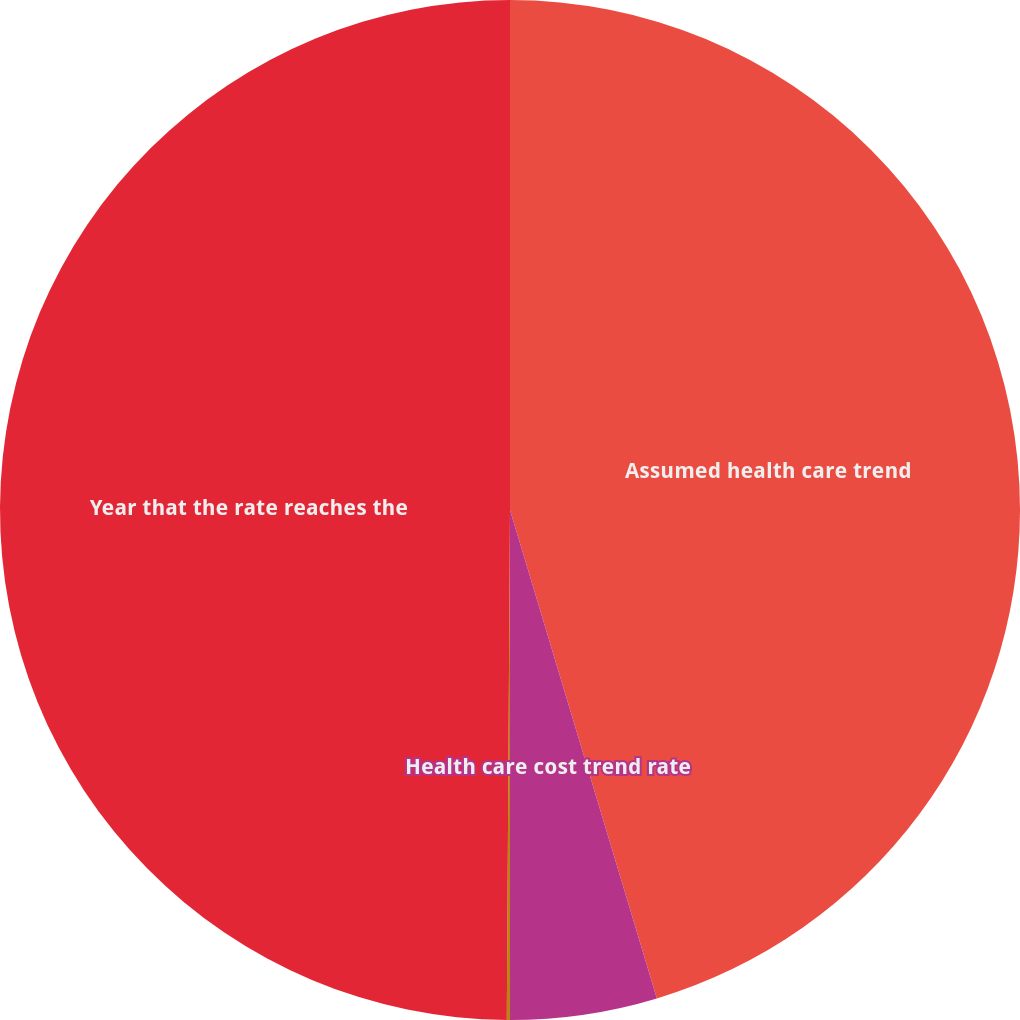<chart> <loc_0><loc_0><loc_500><loc_500><pie_chart><fcel>Assumed health care trend<fcel>Health care cost trend rate<fcel>Rate to which the cost trend<fcel>Year that the rate reaches the<nl><fcel>45.35%<fcel>4.65%<fcel>0.1%<fcel>49.9%<nl></chart> 